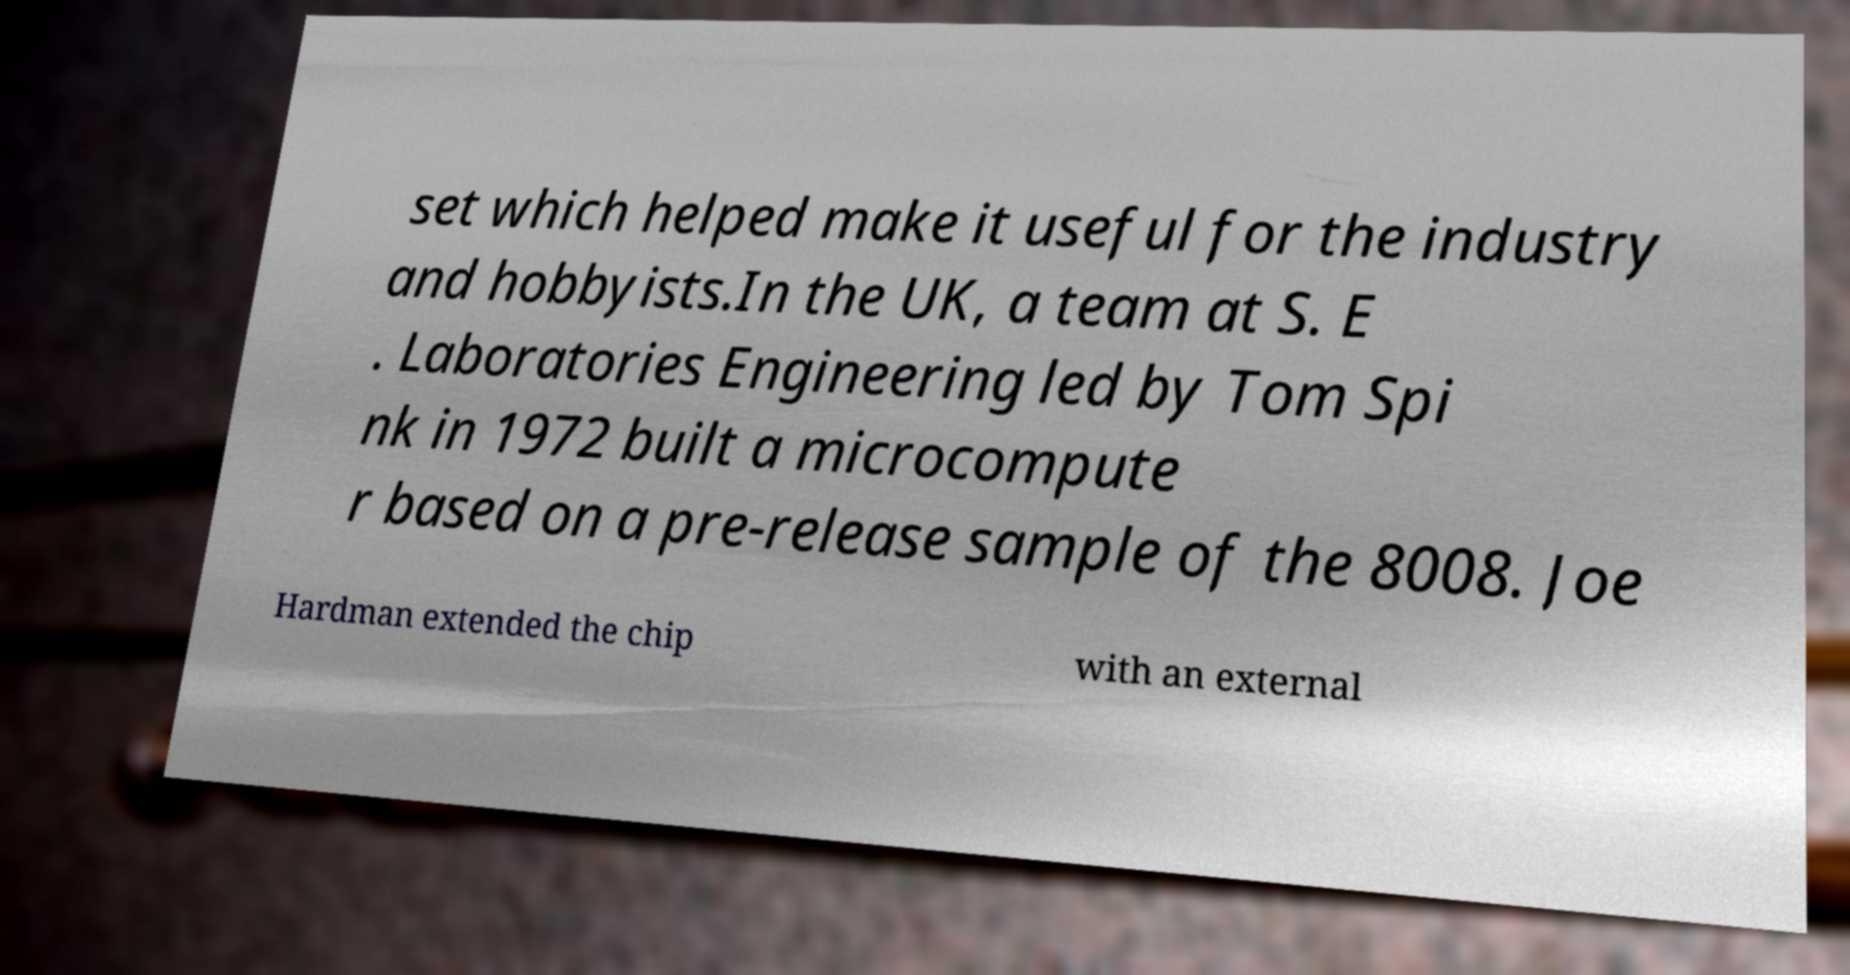What messages or text are displayed in this image? I need them in a readable, typed format. set which helped make it useful for the industry and hobbyists.In the UK, a team at S. E . Laboratories Engineering led by Tom Spi nk in 1972 built a microcompute r based on a pre-release sample of the 8008. Joe Hardman extended the chip with an external 